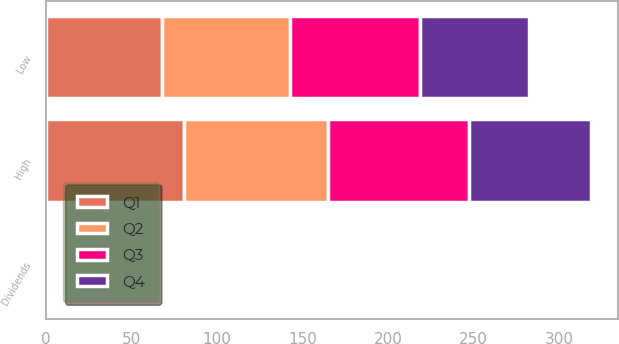Convert chart. <chart><loc_0><loc_0><loc_500><loc_500><stacked_bar_chart><ecel><fcel>Dividends<fcel>High<fcel>Low<nl><fcel>Q4<fcel>0.34<fcel>71.5<fcel>63.66<nl><fcel>Q1<fcel>0.34<fcel>80.5<fcel>67.88<nl><fcel>Q3<fcel>0.4<fcel>82.59<fcel>76.02<nl><fcel>Q2<fcel>0.4<fcel>84.12<fcel>74.62<nl></chart> 